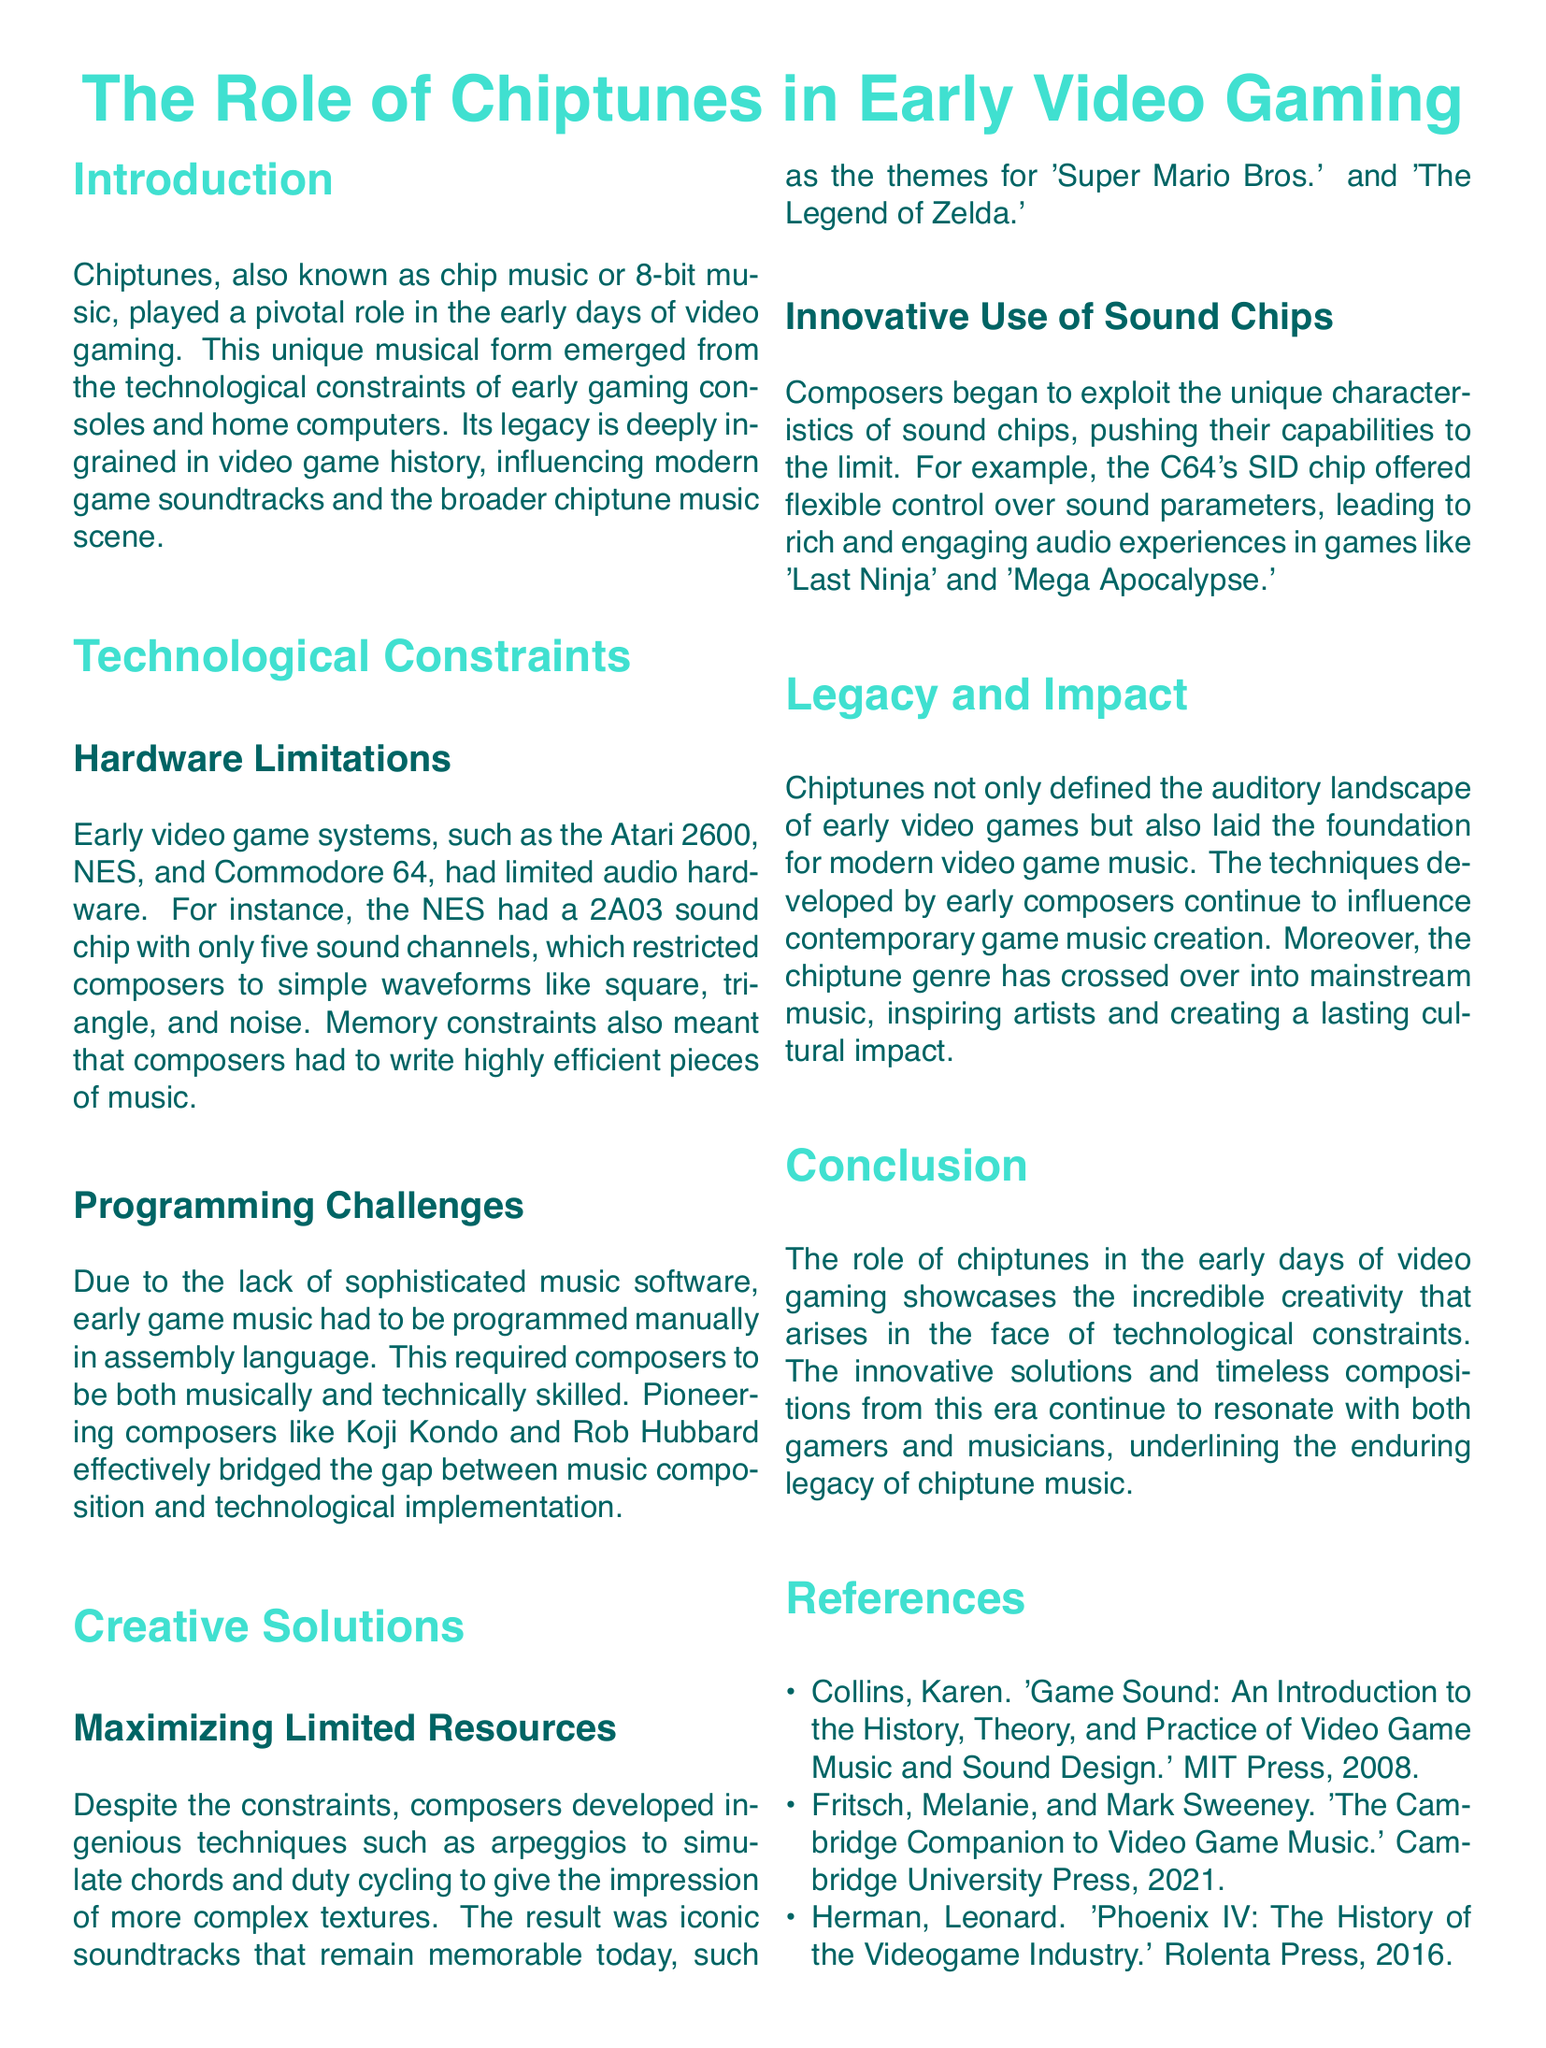What is chiptunes also known as? The document mentions that chiptunes are also referred to as chip music or 8-bit music.
Answer: chip music or 8-bit music Which sound chip did the NES have? The document states that the NES had a 2A03 sound chip.
Answer: 2A03 What musical technique was used to simulate chords? The document notes that composers developed techniques such as arpeggios to simulate chords.
Answer: arpeggios Which composers are highlighted for bridging music composition and technological implementation? The document specifically mentions Koji Kondo and Rob Hubbard as pioneering composers.
Answer: Koji Kondo and Rob Hubbard What unique characteristic of the C64's SID chip is mentioned? The document indicates that the SID chip offered flexible control over sound parameters.
Answer: flexible control over sound parameters What iconic theme is associated with the game 'Super Mario Bros.'? The document refers to the iconic soundtrack of 'Super Mario Bros.' as a result of creative solutions in chiptunes.
Answer: Super Mario Bros What significant impact did chiptunes have on modern music? The document states that techniques developed by early composers continue to influence contemporary game music creation.
Answer: influence contemporary game music creation What year was "Game Sound: An Introduction to the History, Theory, and Practice of Video Game Music and Sound Design" published? The document lists the publication year of "Game Sound" as 2008.
Answer: 2008 